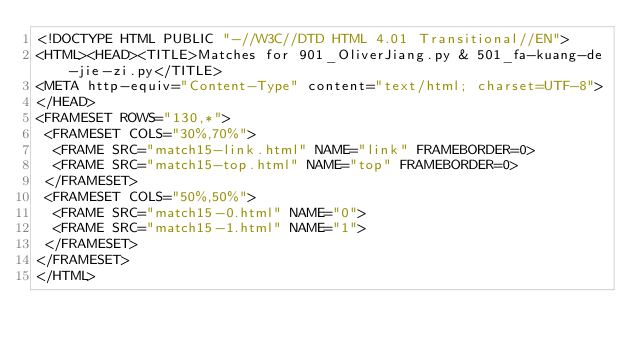<code> <loc_0><loc_0><loc_500><loc_500><_HTML_><!DOCTYPE HTML PUBLIC "-//W3C//DTD HTML 4.01 Transitional//EN">
<HTML><HEAD><TITLE>Matches for 901_OliverJiang.py & 501_fa-kuang-de-jie-zi.py</TITLE>
<META http-equiv="Content-Type" content="text/html; charset=UTF-8">
</HEAD>
<FRAMESET ROWS="130,*">
 <FRAMESET COLS="30%,70%">
  <FRAME SRC="match15-link.html" NAME="link" FRAMEBORDER=0>
  <FRAME SRC="match15-top.html" NAME="top" FRAMEBORDER=0>
 </FRAMESET>
 <FRAMESET COLS="50%,50%">
  <FRAME SRC="match15-0.html" NAME="0">
  <FRAME SRC="match15-1.html" NAME="1">
 </FRAMESET>
</FRAMESET>
</HTML>
</code> 